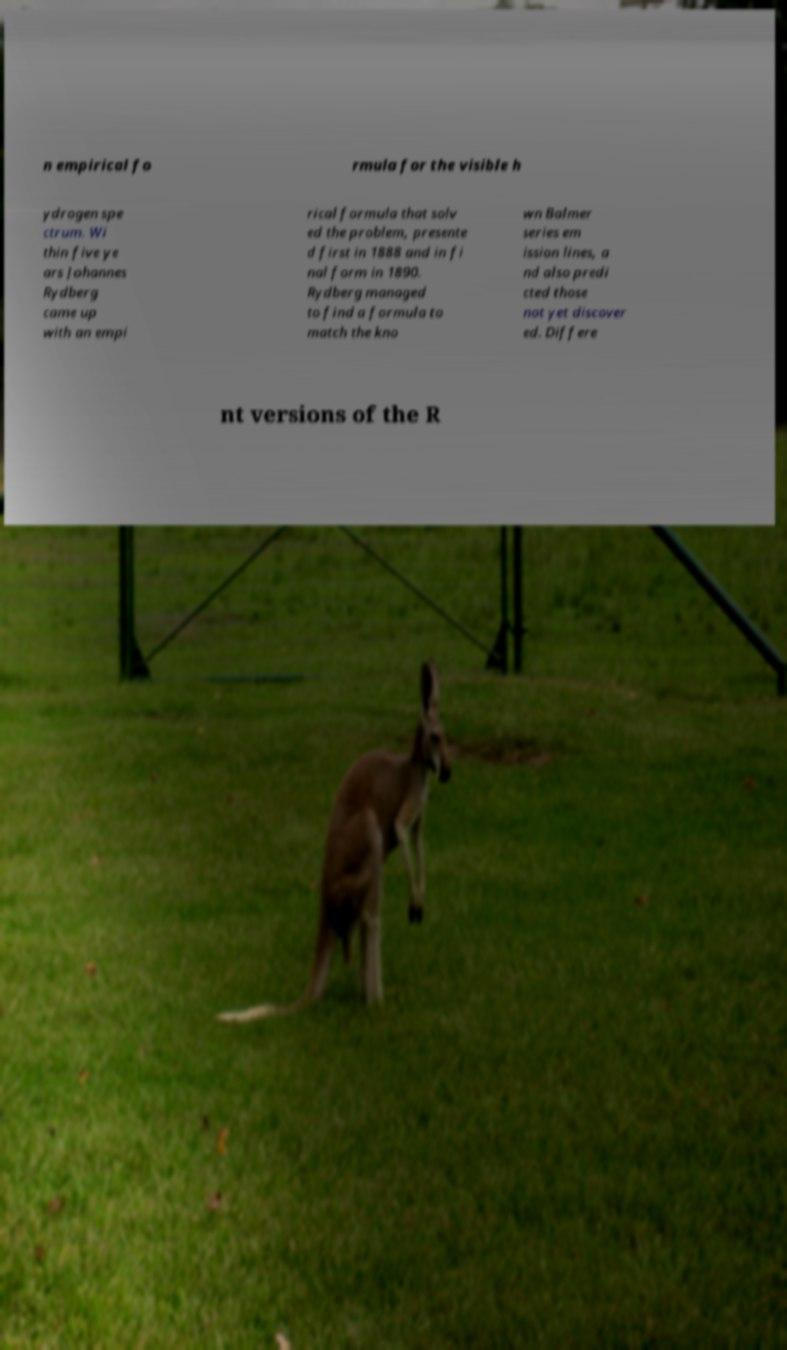There's text embedded in this image that I need extracted. Can you transcribe it verbatim? n empirical fo rmula for the visible h ydrogen spe ctrum. Wi thin five ye ars Johannes Rydberg came up with an empi rical formula that solv ed the problem, presente d first in 1888 and in fi nal form in 1890. Rydberg managed to find a formula to match the kno wn Balmer series em ission lines, a nd also predi cted those not yet discover ed. Differe nt versions of the R 